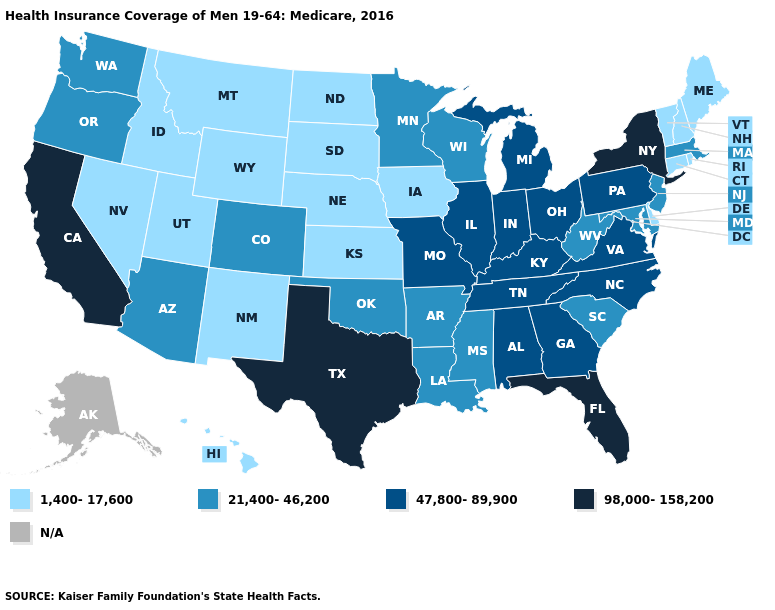Name the states that have a value in the range 21,400-46,200?
Be succinct. Arizona, Arkansas, Colorado, Louisiana, Maryland, Massachusetts, Minnesota, Mississippi, New Jersey, Oklahoma, Oregon, South Carolina, Washington, West Virginia, Wisconsin. Name the states that have a value in the range N/A?
Give a very brief answer. Alaska. What is the highest value in states that border Louisiana?
Short answer required. 98,000-158,200. Which states hav the highest value in the West?
Quick response, please. California. Which states have the lowest value in the USA?
Be succinct. Connecticut, Delaware, Hawaii, Idaho, Iowa, Kansas, Maine, Montana, Nebraska, Nevada, New Hampshire, New Mexico, North Dakota, Rhode Island, South Dakota, Utah, Vermont, Wyoming. Among the states that border Ohio , does Pennsylvania have the highest value?
Write a very short answer. Yes. Does South Dakota have the highest value in the MidWest?
Write a very short answer. No. What is the highest value in the South ?
Concise answer only. 98,000-158,200. Is the legend a continuous bar?
Answer briefly. No. Name the states that have a value in the range 21,400-46,200?
Be succinct. Arizona, Arkansas, Colorado, Louisiana, Maryland, Massachusetts, Minnesota, Mississippi, New Jersey, Oklahoma, Oregon, South Carolina, Washington, West Virginia, Wisconsin. What is the value of Montana?
Keep it brief. 1,400-17,600. What is the value of Maine?
Short answer required. 1,400-17,600. What is the value of New Mexico?
Keep it brief. 1,400-17,600. Does Kentucky have the lowest value in the South?
Concise answer only. No. What is the highest value in the South ?
Concise answer only. 98,000-158,200. 